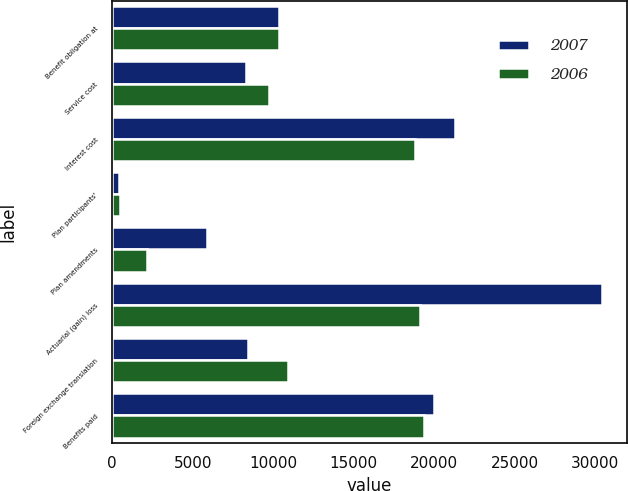<chart> <loc_0><loc_0><loc_500><loc_500><stacked_bar_chart><ecel><fcel>Benefit obligation at<fcel>Service cost<fcel>Interest cost<fcel>Plan participants'<fcel>Plan amendments<fcel>Actuarial (gain) loss<fcel>Foreign exchange translation<fcel>Benefits paid<nl><fcel>2007<fcel>10340.5<fcel>8306<fcel>21306<fcel>392<fcel>5914<fcel>30430<fcel>8440<fcel>20019<nl><fcel>2006<fcel>10340.5<fcel>9740<fcel>18804<fcel>492<fcel>2187<fcel>19142<fcel>10941<fcel>19373<nl></chart> 